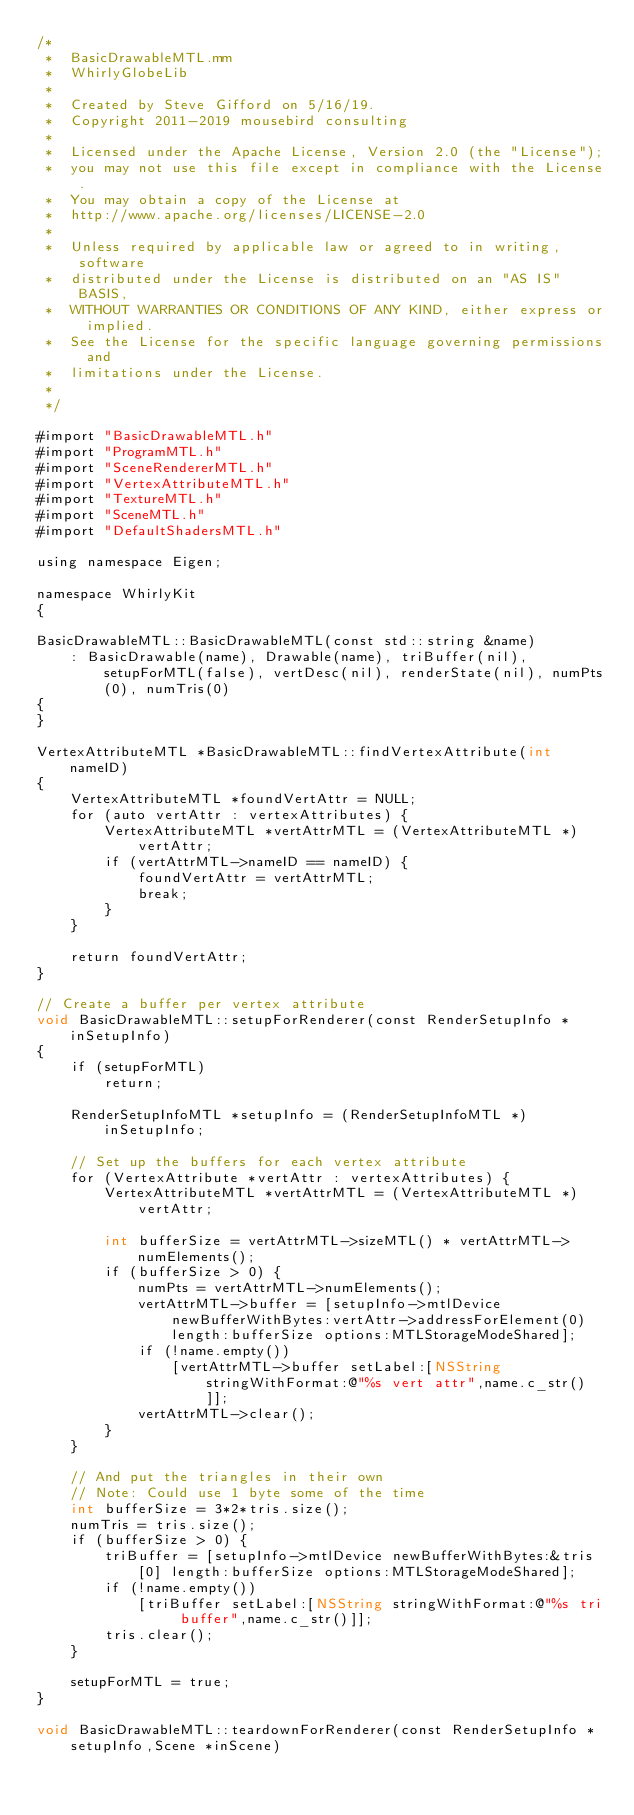<code> <loc_0><loc_0><loc_500><loc_500><_ObjectiveC_>/*
 *  BasicDrawableMTL.mm
 *  WhirlyGlobeLib
 *
 *  Created by Steve Gifford on 5/16/19.
 *  Copyright 2011-2019 mousebird consulting
 *
 *  Licensed under the Apache License, Version 2.0 (the "License");
 *  you may not use this file except in compliance with the License.
 *  You may obtain a copy of the License at
 *  http://www.apache.org/licenses/LICENSE-2.0
 *
 *  Unless required by applicable law or agreed to in writing, software
 *  distributed under the License is distributed on an "AS IS" BASIS,
 *  WITHOUT WARRANTIES OR CONDITIONS OF ANY KIND, either express or implied.
 *  See the License for the specific language governing permissions and
 *  limitations under the License.
 *
 */

#import "BasicDrawableMTL.h"
#import "ProgramMTL.h"
#import "SceneRendererMTL.h"
#import "VertexAttributeMTL.h"
#import "TextureMTL.h"
#import "SceneMTL.h"
#import "DefaultShadersMTL.h"

using namespace Eigen;

namespace WhirlyKit
{
    
BasicDrawableMTL::BasicDrawableMTL(const std::string &name)
    : BasicDrawable(name), Drawable(name), triBuffer(nil), setupForMTL(false), vertDesc(nil), renderState(nil), numPts(0), numTris(0)
{
}

VertexAttributeMTL *BasicDrawableMTL::findVertexAttribute(int nameID)
{
    VertexAttributeMTL *foundVertAttr = NULL;
    for (auto vertAttr : vertexAttributes) {
        VertexAttributeMTL *vertAttrMTL = (VertexAttributeMTL *)vertAttr;
        if (vertAttrMTL->nameID == nameID) {
            foundVertAttr = vertAttrMTL;
            break;
        }
    }
    
    return foundVertAttr;
}
 
// Create a buffer per vertex attribute
void BasicDrawableMTL::setupForRenderer(const RenderSetupInfo *inSetupInfo)
{
    if (setupForMTL)
        return;
    
    RenderSetupInfoMTL *setupInfo = (RenderSetupInfoMTL *)inSetupInfo;
    
    // Set up the buffers for each vertex attribute
    for (VertexAttribute *vertAttr : vertexAttributes) {
        VertexAttributeMTL *vertAttrMTL = (VertexAttributeMTL *)vertAttr;
        
        int bufferSize = vertAttrMTL->sizeMTL() * vertAttrMTL->numElements();
        if (bufferSize > 0) {
            numPts = vertAttrMTL->numElements();
            vertAttrMTL->buffer = [setupInfo->mtlDevice newBufferWithBytes:vertAttr->addressForElement(0) length:bufferSize options:MTLStorageModeShared];
            if (!name.empty())
                [vertAttrMTL->buffer setLabel:[NSString stringWithFormat:@"%s vert attr",name.c_str()]];
            vertAttrMTL->clear();
        }
    }
    
    // And put the triangles in their own
    // Note: Could use 1 byte some of the time
    int bufferSize = 3*2*tris.size();
    numTris = tris.size();
    if (bufferSize > 0) {
        triBuffer = [setupInfo->mtlDevice newBufferWithBytes:&tris[0] length:bufferSize options:MTLStorageModeShared];
        if (!name.empty())
            [triBuffer setLabel:[NSString stringWithFormat:@"%s tri buffer",name.c_str()]];
        tris.clear();
    }
    
    setupForMTL = true;
}

void BasicDrawableMTL::teardownForRenderer(const RenderSetupInfo *setupInfo,Scene *inScene)</code> 